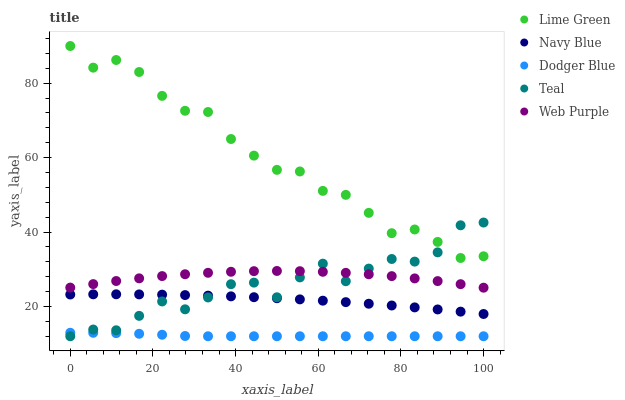Does Dodger Blue have the minimum area under the curve?
Answer yes or no. Yes. Does Lime Green have the maximum area under the curve?
Answer yes or no. Yes. Does Web Purple have the minimum area under the curve?
Answer yes or no. No. Does Web Purple have the maximum area under the curve?
Answer yes or no. No. Is Dodger Blue the smoothest?
Answer yes or no. Yes. Is Teal the roughest?
Answer yes or no. Yes. Is Web Purple the smoothest?
Answer yes or no. No. Is Web Purple the roughest?
Answer yes or no. No. Does Teal have the lowest value?
Answer yes or no. Yes. Does Web Purple have the lowest value?
Answer yes or no. No. Does Lime Green have the highest value?
Answer yes or no. Yes. Does Web Purple have the highest value?
Answer yes or no. No. Is Dodger Blue less than Navy Blue?
Answer yes or no. Yes. Is Web Purple greater than Dodger Blue?
Answer yes or no. Yes. Does Web Purple intersect Teal?
Answer yes or no. Yes. Is Web Purple less than Teal?
Answer yes or no. No. Is Web Purple greater than Teal?
Answer yes or no. No. Does Dodger Blue intersect Navy Blue?
Answer yes or no. No. 